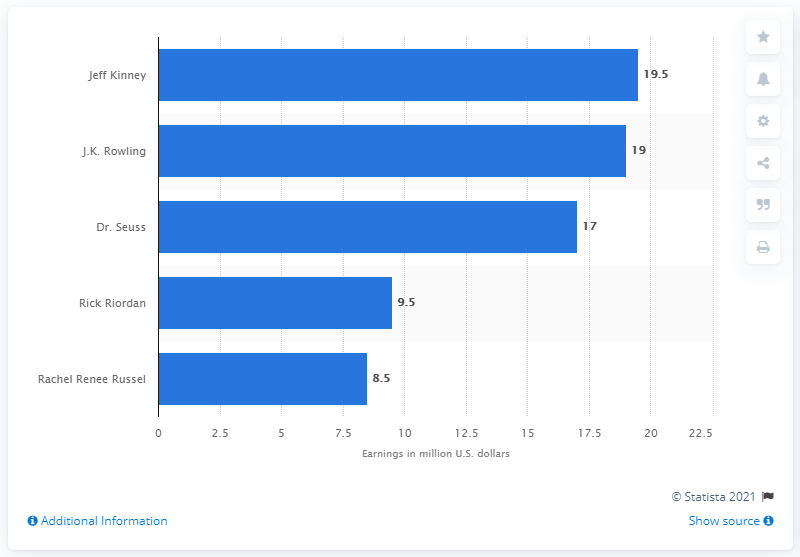Outline some significant characteristics in this image. In the period from June 2015 to June 2016, Jeff Kinney earned approximately 19.5 million dollars. Jeff Kinney was the wealthiest children's author worldwide from June 2015 to June 2016. 